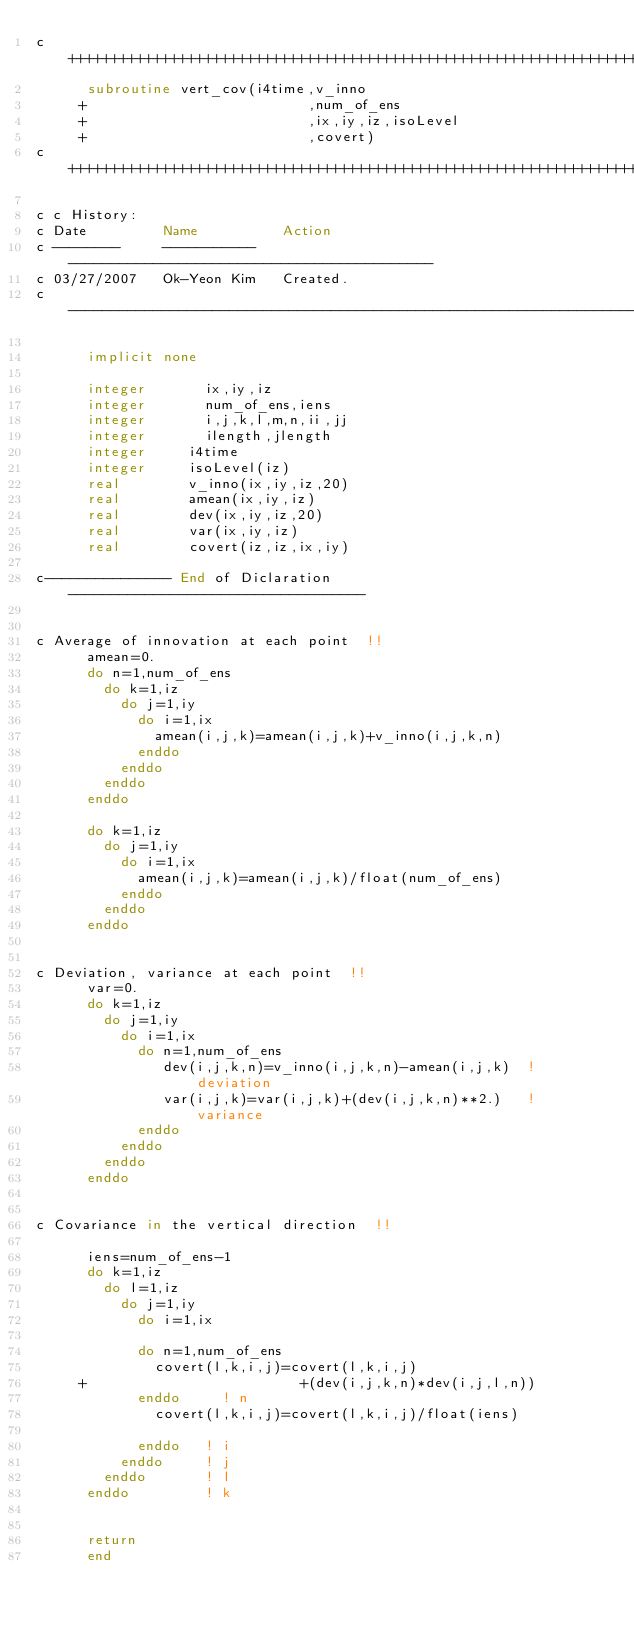<code> <loc_0><loc_0><loc_500><loc_500><_FORTRAN_>c+++++++++++++++++++++++++++++++++++++++++++++++++++++++++++++++++++++++
      subroutine vert_cov(i4time,v_inno
     +                          ,num_of_ens
     +                          ,ix,iy,iz,isoLevel
     +                          ,covert)
c+++++++++++++++++++++++++++++++++++++++++++++++++++++++++++++++++++++++

c c History:
c Date         Name          Action
c --------     -----------   -------------------------------------------
c 03/27/2007   Ok-Yeon Kim   Created. 
c ----------------------------------------------------------------------

      implicit none

      integer       ix,iy,iz
      integer       num_of_ens,iens
      integer       i,j,k,l,m,n,ii,jj
      integer       ilength,jlength
      integer     i4time
      integer     isoLevel(iz)
      real        v_inno(ix,iy,iz,20)
      real        amean(ix,iy,iz)
      real        dev(ix,iy,iz,20)
      real        var(ix,iy,iz)
      real        covert(iz,iz,ix,iy)

c--------------- End of Diclaration -----------------------------------


c Average of innovation at each point  !!
      amean=0.
      do n=1,num_of_ens
        do k=1,iz
          do j=1,iy
            do i=1,ix
              amean(i,j,k)=amean(i,j,k)+v_inno(i,j,k,n)
            enddo 
          enddo
        enddo
      enddo

      do k=1,iz
        do j=1,iy
          do i=1,ix
            amean(i,j,k)=amean(i,j,k)/float(num_of_ens)
          enddo
        enddo
      enddo


c Deviation, variance at each point  !!
      var=0.
      do k=1,iz
        do j=1,iy  
          do i=1,ix
            do n=1,num_of_ens
               dev(i,j,k,n)=v_inno(i,j,k,n)-amean(i,j,k)  ! deviation
               var(i,j,k)=var(i,j,k)+(dev(i,j,k,n)**2.)   ! variance
            enddo
          enddo
        enddo
      enddo


c Covariance in the vertical direction  !!

      iens=num_of_ens-1            
      do k=1,iz
        do l=1,iz
          do j=1,iy
            do i=1,ix

            do n=1,num_of_ens
              covert(l,k,i,j)=covert(l,k,i,j)
     +                         +(dev(i,j,k,n)*dev(i,j,l,n))
            enddo     ! n
              covert(l,k,i,j)=covert(l,k,i,j)/float(iens)

            enddo   ! i
          enddo     ! j
        enddo       ! l
      enddo         ! k


      return
      end
</code> 